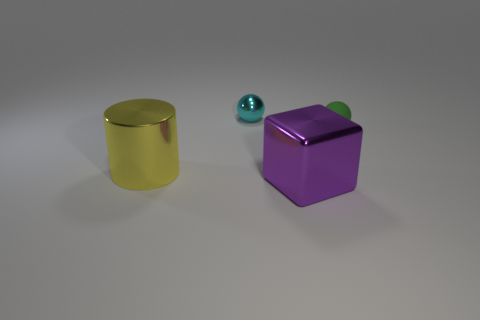Add 3 yellow rubber spheres. How many objects exist? 7 Subtract all green spheres. How many spheres are left? 1 Add 1 green spheres. How many green spheres are left? 2 Add 1 gray things. How many gray things exist? 1 Subtract 0 yellow blocks. How many objects are left? 4 Subtract all cylinders. How many objects are left? 3 Subtract all cyan spheres. Subtract all gray cubes. How many spheres are left? 1 Subtract all cyan rubber spheres. Subtract all big yellow cylinders. How many objects are left? 3 